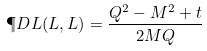<formula> <loc_0><loc_0><loc_500><loc_500>\P D L ( L , L ) = \frac { Q ^ { 2 } - M ^ { 2 } + t } { 2 M Q }</formula> 